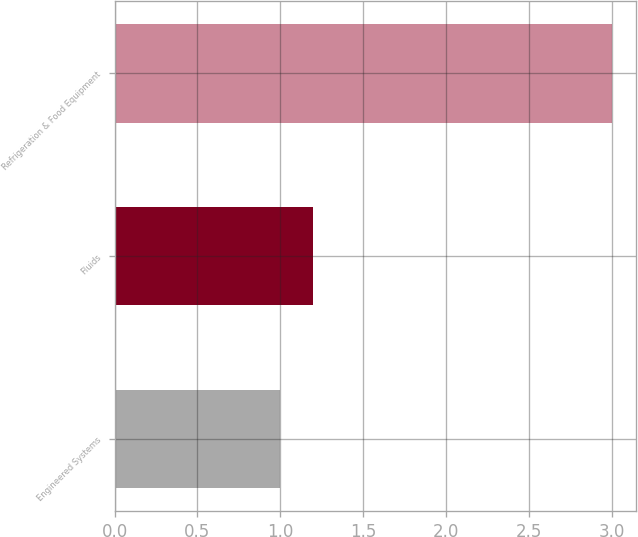Convert chart to OTSL. <chart><loc_0><loc_0><loc_500><loc_500><bar_chart><fcel>Engineered Systems<fcel>Fluids<fcel>Refrigeration & Food Equipment<nl><fcel>1<fcel>1.2<fcel>3<nl></chart> 